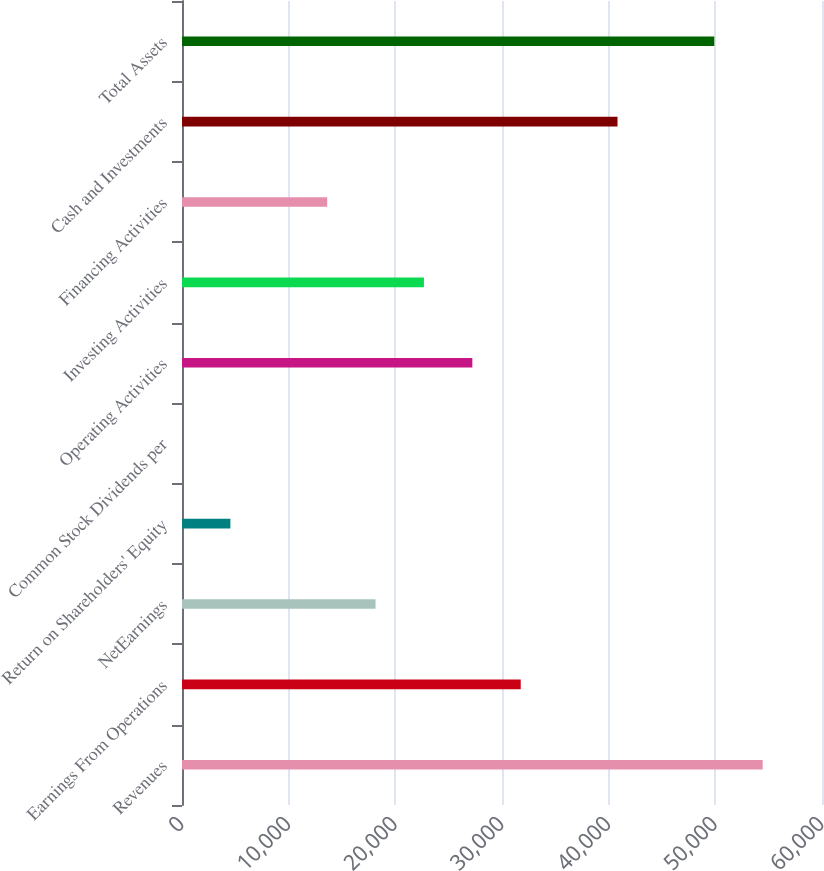Convert chart. <chart><loc_0><loc_0><loc_500><loc_500><bar_chart><fcel>Revenues<fcel>Earnings From Operations<fcel>NetEarnings<fcel>Return on Shareholders' Equity<fcel>Common Stock Dividends per<fcel>Operating Activities<fcel>Investing Activities<fcel>Financing Activities<fcel>Cash and Investments<fcel>Total Assets<nl><fcel>54438<fcel>31755.5<fcel>18146<fcel>4536.51<fcel>0.01<fcel>27219<fcel>22682.5<fcel>13609.5<fcel>40828.5<fcel>49901.5<nl></chart> 